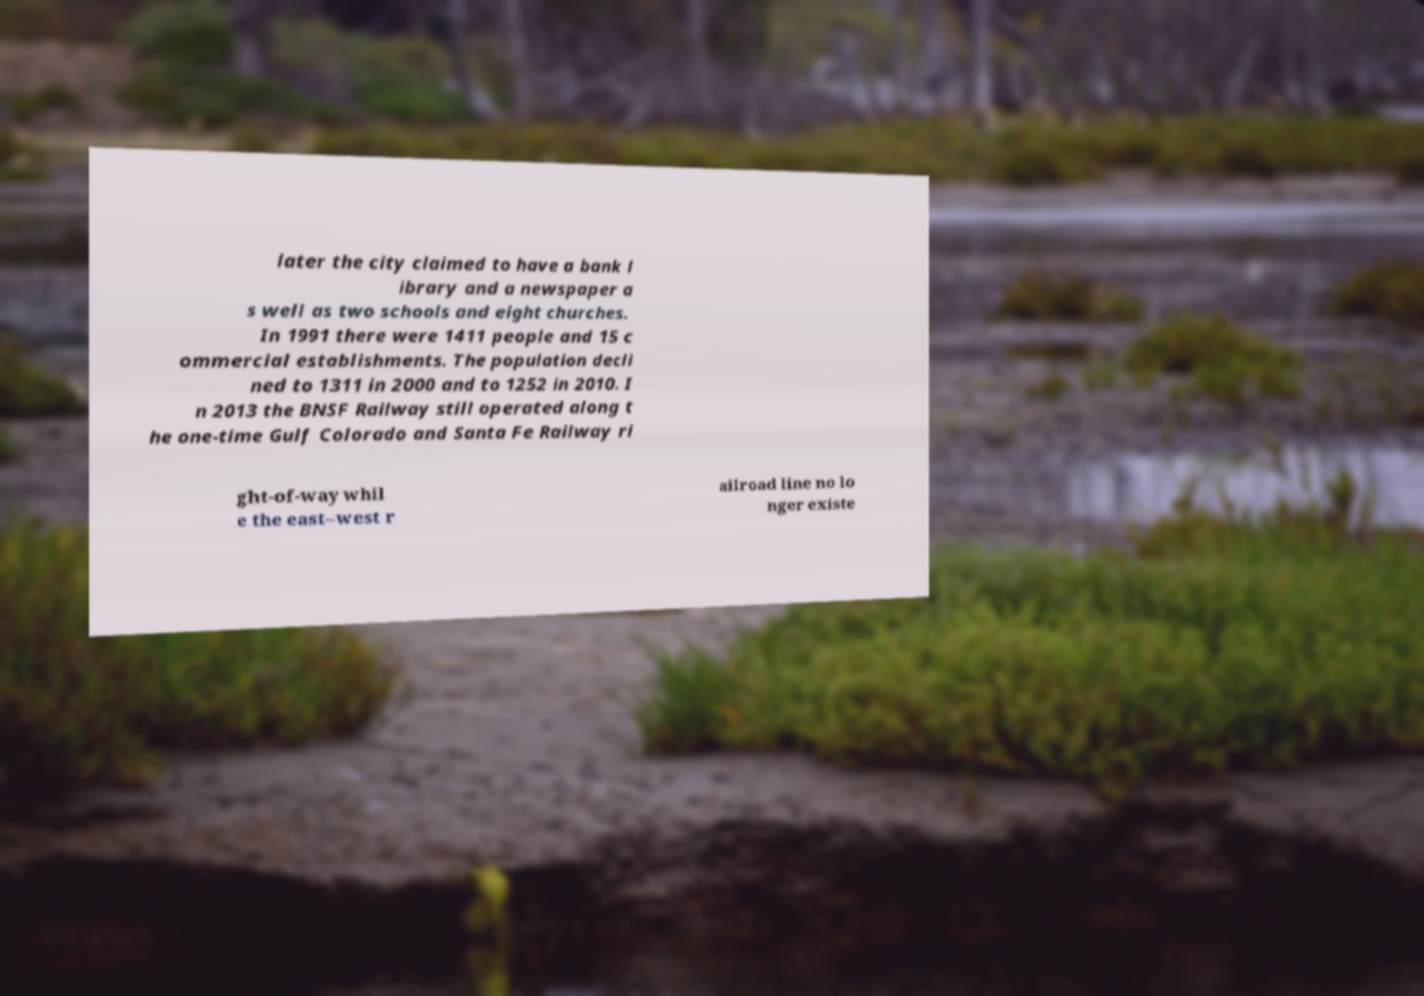Could you assist in decoding the text presented in this image and type it out clearly? later the city claimed to have a bank l ibrary and a newspaper a s well as two schools and eight churches. In 1991 there were 1411 people and 15 c ommercial establishments. The population decli ned to 1311 in 2000 and to 1252 in 2010. I n 2013 the BNSF Railway still operated along t he one-time Gulf Colorado and Santa Fe Railway ri ght-of-way whil e the east–west r ailroad line no lo nger existe 